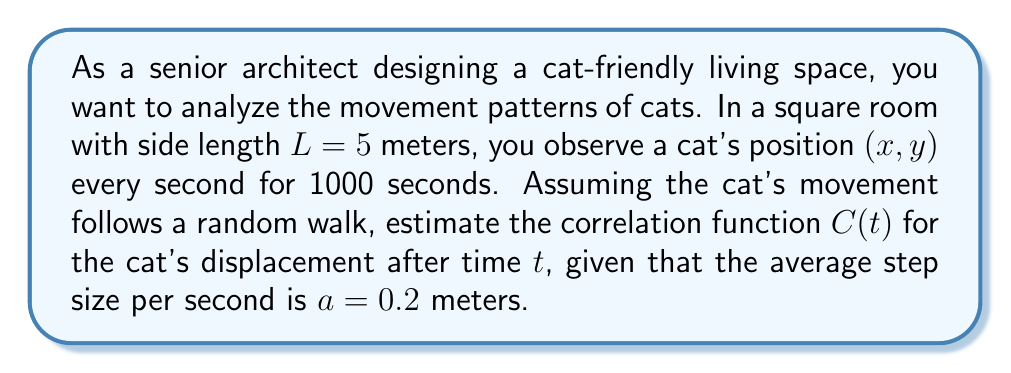Show me your answer to this math problem. To estimate the correlation function for the cat's movement, we'll follow these steps:

1. In a random walk model, the mean square displacement $\langle r^2(t) \rangle$ is proportional to time:

   $$\langle r^2(t) \rangle = 2dDt$$

   where $d$ is the dimensionality (2 for a 2D space) and $D$ is the diffusion coefficient.

2. The diffusion coefficient $D$ is related to the average step size $a$ and the time step $\Delta t$ (1 second in this case):

   $$D = \frac{a^2}{2d\Delta t} = \frac{(0.2\text{ m})^2}{2 \cdot 2 \cdot 1\text{ s}} = 0.01\text{ m}^2/\text{s}$$

3. The correlation function $C(t)$ for a random walk is given by:

   $$C(t) = \langle \mathbf{r}(t) \cdot \mathbf{r}(0) \rangle = 2dD\tau e^{-t/\tau}$$

   where $\tau$ is the correlation time.

4. In an enclosed space, the correlation time $\tau$ is related to the room size $L$ and the diffusion coefficient $D$:

   $$\tau \approx \frac{L^2}{2dD} = \frac{(5\text{ m})^2}{2 \cdot 2 \cdot 0.01\text{ m}^2/\text{s}} = 625\text{ s}$$

5. Substituting these values into the correlation function:

   $$C(t) = 2 \cdot 2 \cdot 0.01\text{ m}^2/\text{s} \cdot 625\text{ s} \cdot e^{-t/625\text{ s}}$$

6. Simplifying:

   $$C(t) = 25e^{-t/625}\text{ m}^2$$

This function describes how the cat's position at time $t$ is correlated with its initial position.
Answer: $C(t) = 25e^{-t/625}\text{ m}^2$ 